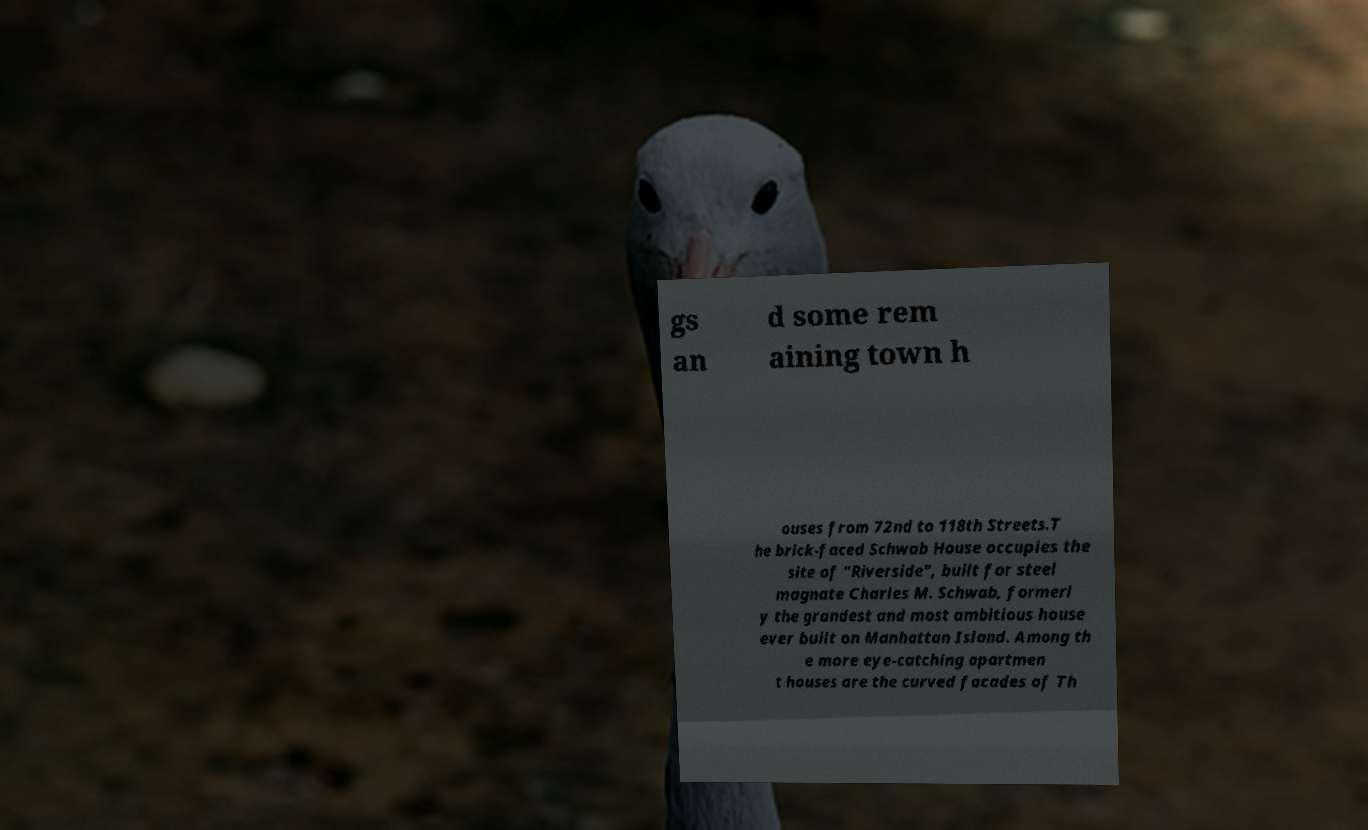Could you assist in decoding the text presented in this image and type it out clearly? gs an d some rem aining town h ouses from 72nd to 118th Streets.T he brick-faced Schwab House occupies the site of "Riverside", built for steel magnate Charles M. Schwab, formerl y the grandest and most ambitious house ever built on Manhattan Island. Among th e more eye-catching apartmen t houses are the curved facades of Th 